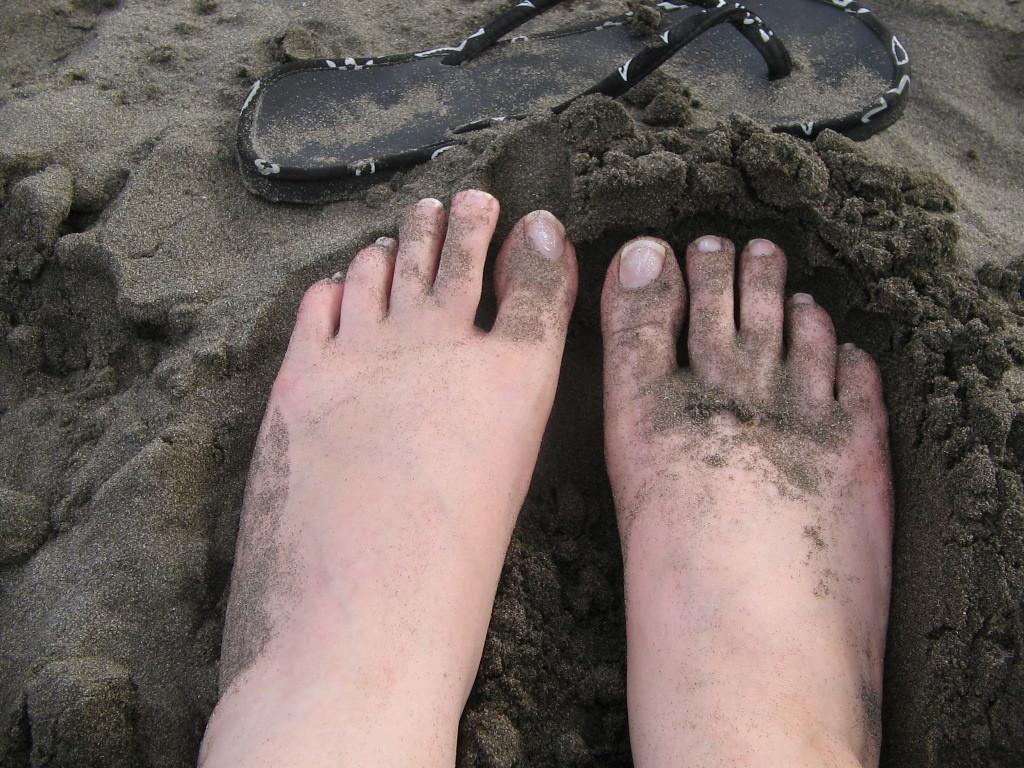What can be seen on the sand in the image? A: Human feet are visible on the sand in the image. What is located at the top of the image? Footwear is present at the top of the image. How many crayons can be seen in the image? There are no crayons present in the image. What type of straw is being used by the cattle in the image? There are no cattle or straw present in the image. 